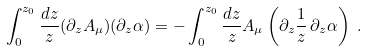<formula> <loc_0><loc_0><loc_500><loc_500>& \int ^ { z _ { 0 } } _ { 0 } \frac { d z } { z } ( \partial _ { z } A _ { \mu } ) ( \partial _ { z } \alpha ) = - \int ^ { z _ { 0 } } _ { 0 } \frac { d z } { z } A _ { \mu } \left ( \partial _ { z } \frac { 1 } { z } \, \partial _ { z } \alpha \right ) \ .</formula> 